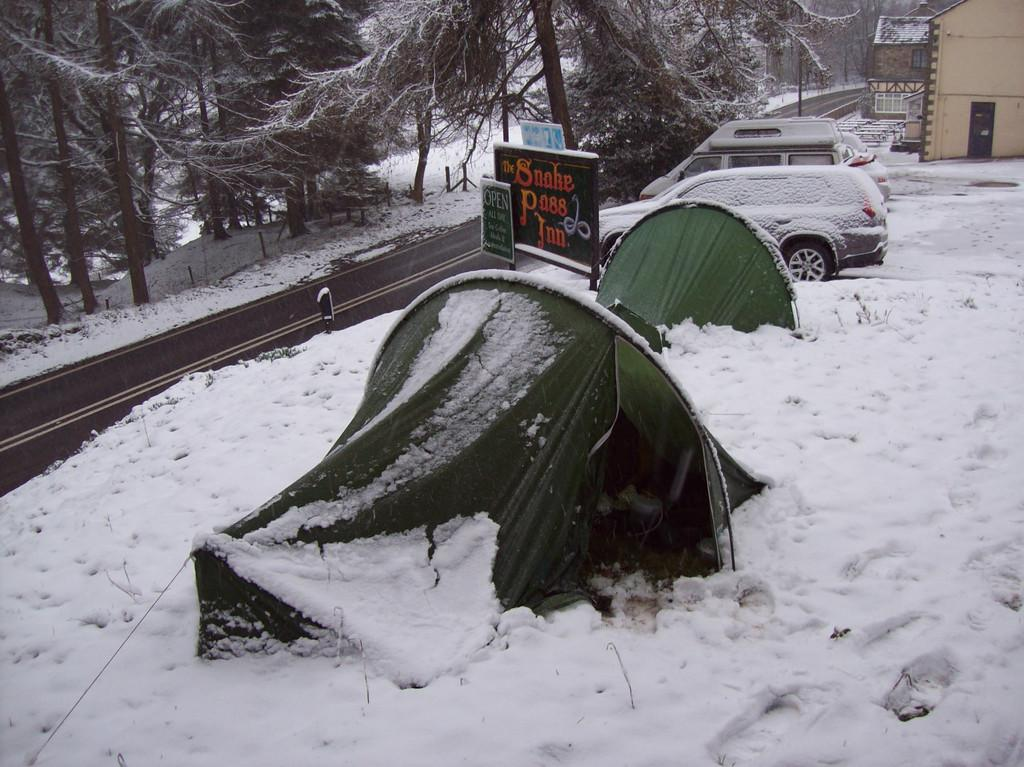<image>
Write a terse but informative summary of the picture. A sign at the entrance of the Snake Pass Inn is covered in snow. 